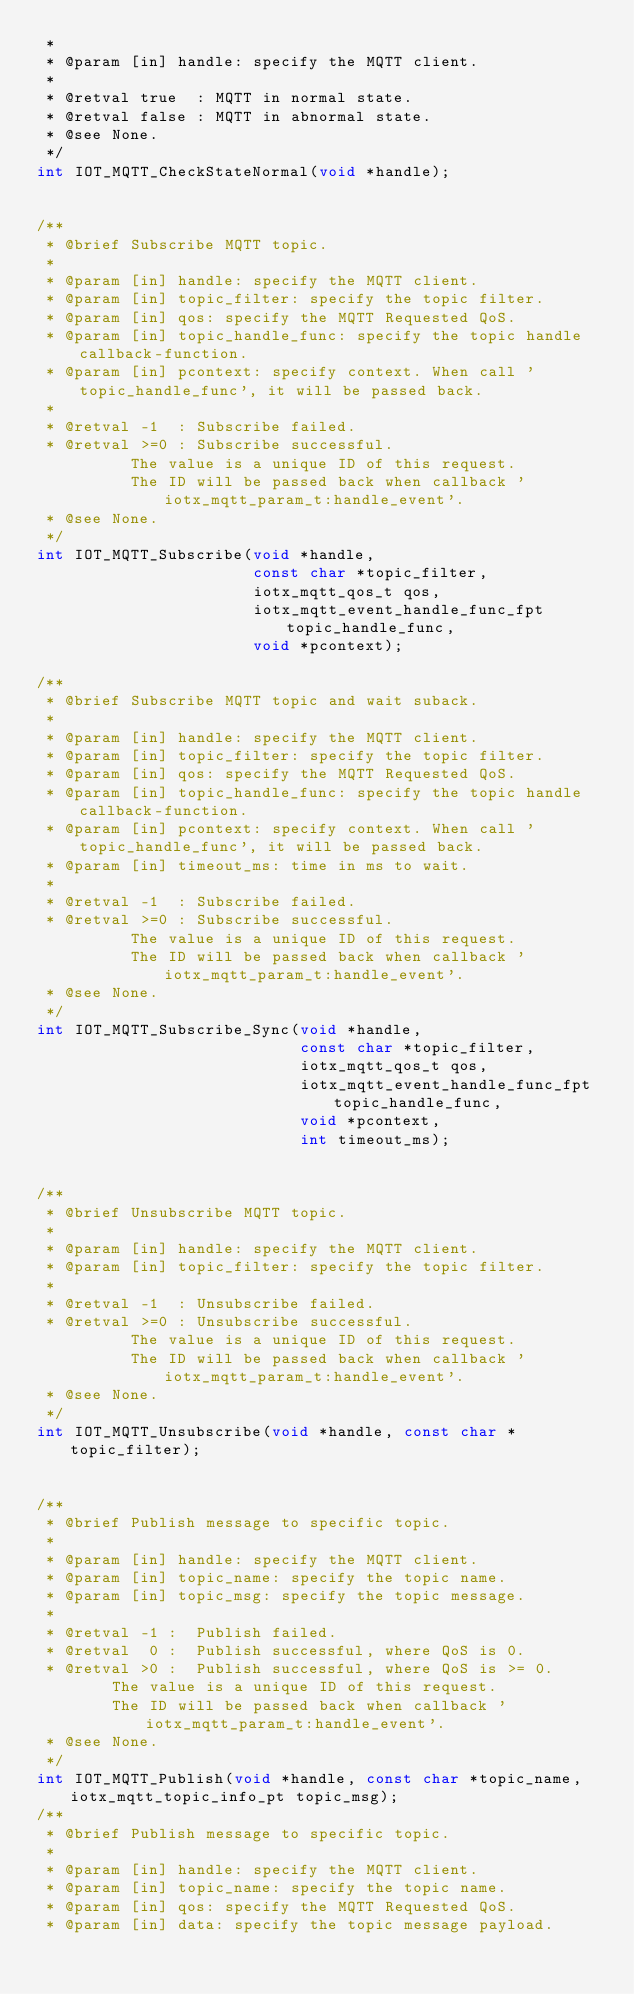<code> <loc_0><loc_0><loc_500><loc_500><_C_> *
 * @param [in] handle: specify the MQTT client.
 *
 * @retval true  : MQTT in normal state.
 * @retval false : MQTT in abnormal state.
 * @see None.
 */
int IOT_MQTT_CheckStateNormal(void *handle);


/**
 * @brief Subscribe MQTT topic.
 *
 * @param [in] handle: specify the MQTT client.
 * @param [in] topic_filter: specify the topic filter.
 * @param [in] qos: specify the MQTT Requested QoS.
 * @param [in] topic_handle_func: specify the topic handle callback-function.
 * @param [in] pcontext: specify context. When call 'topic_handle_func', it will be passed back.
 *
 * @retval -1  : Subscribe failed.
 * @retval >=0 : Subscribe successful.
          The value is a unique ID of this request.
          The ID will be passed back when callback 'iotx_mqtt_param_t:handle_event'.
 * @see None.
 */
int IOT_MQTT_Subscribe(void *handle,
                       const char *topic_filter,
                       iotx_mqtt_qos_t qos,
                       iotx_mqtt_event_handle_func_fpt topic_handle_func,
                       void *pcontext);

/**
 * @brief Subscribe MQTT topic and wait suback.
 *
 * @param [in] handle: specify the MQTT client.
 * @param [in] topic_filter: specify the topic filter.
 * @param [in] qos: specify the MQTT Requested QoS.
 * @param [in] topic_handle_func: specify the topic handle callback-function.
 * @param [in] pcontext: specify context. When call 'topic_handle_func', it will be passed back.
 * @param [in] timeout_ms: time in ms to wait.
 *
 * @retval -1  : Subscribe failed.
 * @retval >=0 : Subscribe successful.
          The value is a unique ID of this request.
          The ID will be passed back when callback 'iotx_mqtt_param_t:handle_event'.
 * @see None.
 */
int IOT_MQTT_Subscribe_Sync(void *handle,
                            const char *topic_filter,
                            iotx_mqtt_qos_t qos,
                            iotx_mqtt_event_handle_func_fpt topic_handle_func,
                            void *pcontext,
                            int timeout_ms);


/**
 * @brief Unsubscribe MQTT topic.
 *
 * @param [in] handle: specify the MQTT client.
 * @param [in] topic_filter: specify the topic filter.
 *
 * @retval -1  : Unsubscribe failed.
 * @retval >=0 : Unsubscribe successful.
          The value is a unique ID of this request.
          The ID will be passed back when callback 'iotx_mqtt_param_t:handle_event'.
 * @see None.
 */
int IOT_MQTT_Unsubscribe(void *handle, const char *topic_filter);


/**
 * @brief Publish message to specific topic.
 *
 * @param [in] handle: specify the MQTT client.
 * @param [in] topic_name: specify the topic name.
 * @param [in] topic_msg: specify the topic message.
 *
 * @retval -1 :  Publish failed.
 * @retval  0 :  Publish successful, where QoS is 0.
 * @retval >0 :  Publish successful, where QoS is >= 0.
        The value is a unique ID of this request.
        The ID will be passed back when callback 'iotx_mqtt_param_t:handle_event'.
 * @see None.
 */
int IOT_MQTT_Publish(void *handle, const char *topic_name, iotx_mqtt_topic_info_pt topic_msg);
/**
 * @brief Publish message to specific topic.
 *
 * @param [in] handle: specify the MQTT client.
 * @param [in] topic_name: specify the topic name.
 * @param [in] qos: specify the MQTT Requested QoS.
 * @param [in] data: specify the topic message payload.</code> 